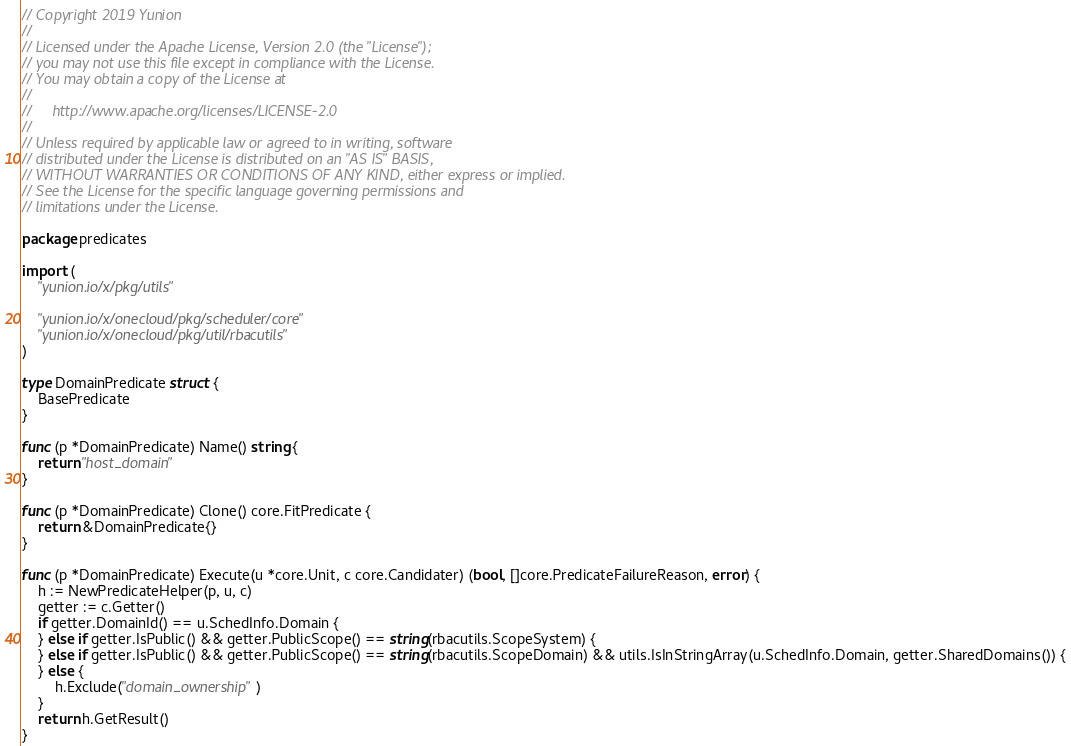<code> <loc_0><loc_0><loc_500><loc_500><_Go_>// Copyright 2019 Yunion
//
// Licensed under the Apache License, Version 2.0 (the "License");
// you may not use this file except in compliance with the License.
// You may obtain a copy of the License at
//
//     http://www.apache.org/licenses/LICENSE-2.0
//
// Unless required by applicable law or agreed to in writing, software
// distributed under the License is distributed on an "AS IS" BASIS,
// WITHOUT WARRANTIES OR CONDITIONS OF ANY KIND, either express or implied.
// See the License for the specific language governing permissions and
// limitations under the License.

package predicates

import (
	"yunion.io/x/pkg/utils"

	"yunion.io/x/onecloud/pkg/scheduler/core"
	"yunion.io/x/onecloud/pkg/util/rbacutils"
)

type DomainPredicate struct {
	BasePredicate
}

func (p *DomainPredicate) Name() string {
	return "host_domain"
}

func (p *DomainPredicate) Clone() core.FitPredicate {
	return &DomainPredicate{}
}

func (p *DomainPredicate) Execute(u *core.Unit, c core.Candidater) (bool, []core.PredicateFailureReason, error) {
	h := NewPredicateHelper(p, u, c)
	getter := c.Getter()
	if getter.DomainId() == u.SchedInfo.Domain {
	} else if getter.IsPublic() && getter.PublicScope() == string(rbacutils.ScopeSystem) {
	} else if getter.IsPublic() && getter.PublicScope() == string(rbacutils.ScopeDomain) && utils.IsInStringArray(u.SchedInfo.Domain, getter.SharedDomains()) {
	} else {
		h.Exclude("domain_ownership")
	}
	return h.GetResult()
}
</code> 